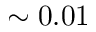<formula> <loc_0><loc_0><loc_500><loc_500>\sim 0 . 0 1</formula> 